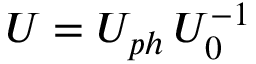<formula> <loc_0><loc_0><loc_500><loc_500>U = U _ { p h } \, U _ { 0 } ^ { - 1 }</formula> 